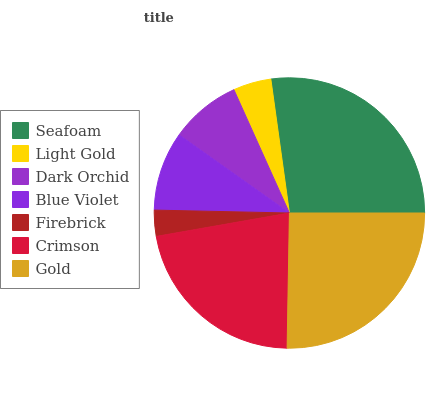Is Firebrick the minimum?
Answer yes or no. Yes. Is Seafoam the maximum?
Answer yes or no. Yes. Is Light Gold the minimum?
Answer yes or no. No. Is Light Gold the maximum?
Answer yes or no. No. Is Seafoam greater than Light Gold?
Answer yes or no. Yes. Is Light Gold less than Seafoam?
Answer yes or no. Yes. Is Light Gold greater than Seafoam?
Answer yes or no. No. Is Seafoam less than Light Gold?
Answer yes or no. No. Is Blue Violet the high median?
Answer yes or no. Yes. Is Blue Violet the low median?
Answer yes or no. Yes. Is Crimson the high median?
Answer yes or no. No. Is Dark Orchid the low median?
Answer yes or no. No. 